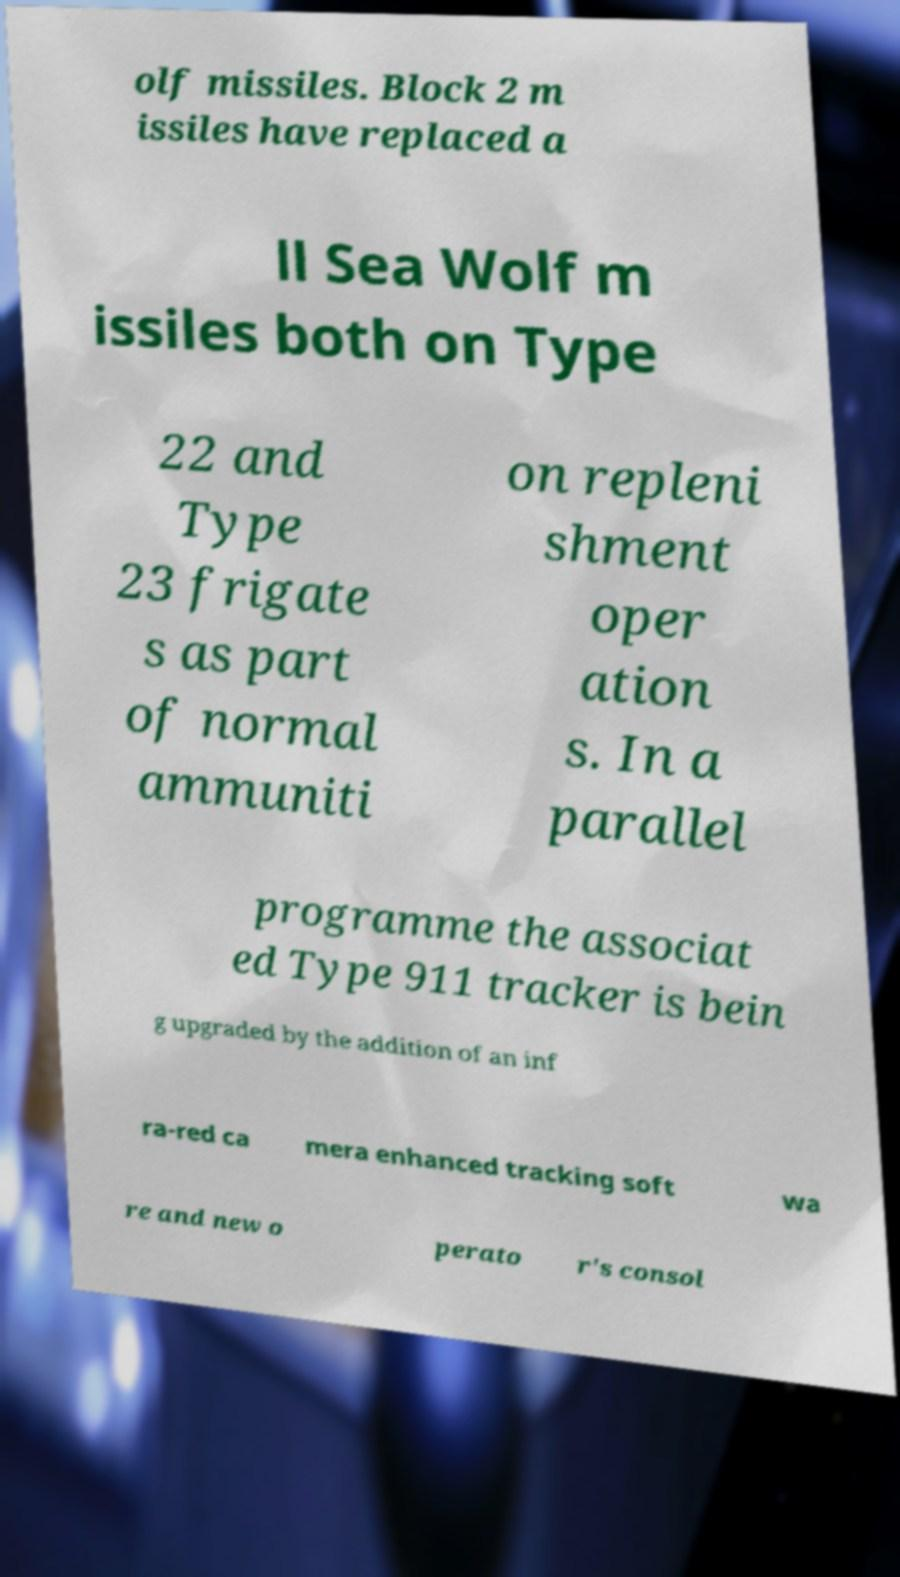Can you accurately transcribe the text from the provided image for me? olf missiles. Block 2 m issiles have replaced a ll Sea Wolf m issiles both on Type 22 and Type 23 frigate s as part of normal ammuniti on repleni shment oper ation s. In a parallel programme the associat ed Type 911 tracker is bein g upgraded by the addition of an inf ra-red ca mera enhanced tracking soft wa re and new o perato r's consol 